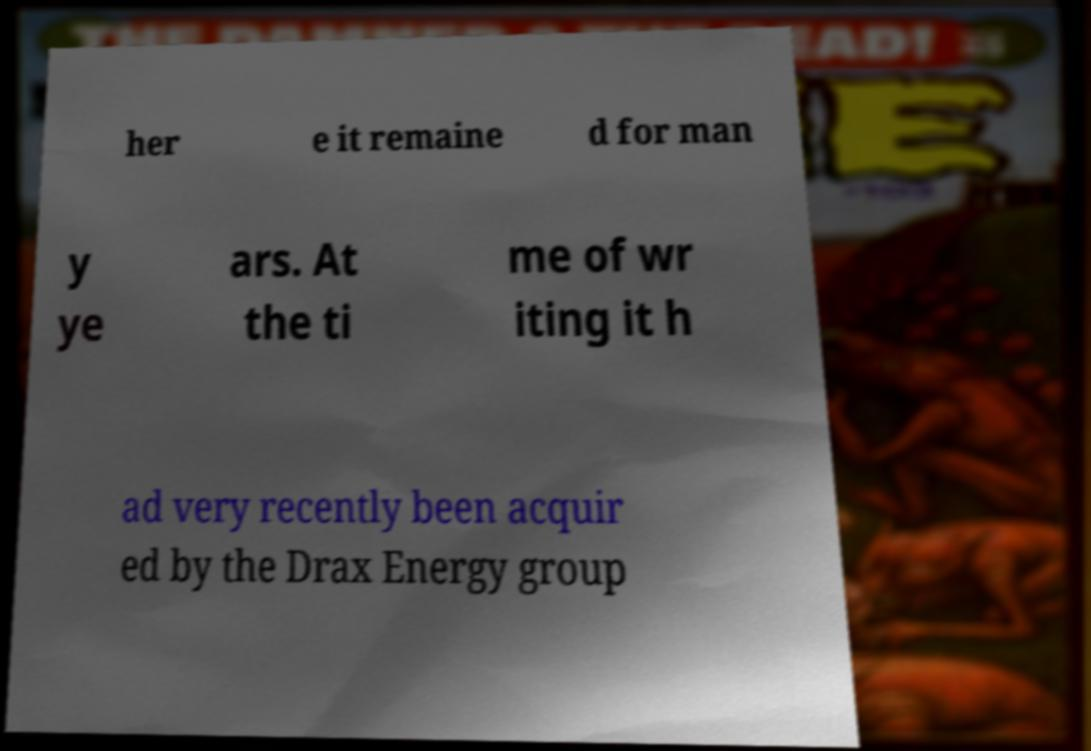Could you assist in decoding the text presented in this image and type it out clearly? her e it remaine d for man y ye ars. At the ti me of wr iting it h ad very recently been acquir ed by the Drax Energy group 